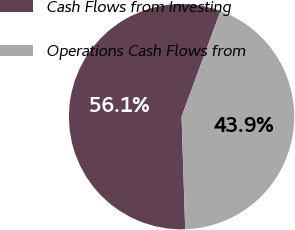Convert chart to OTSL. <chart><loc_0><loc_0><loc_500><loc_500><pie_chart><fcel>Cash Flows from Investing<fcel>Operations Cash Flows from<nl><fcel>56.13%<fcel>43.87%<nl></chart> 